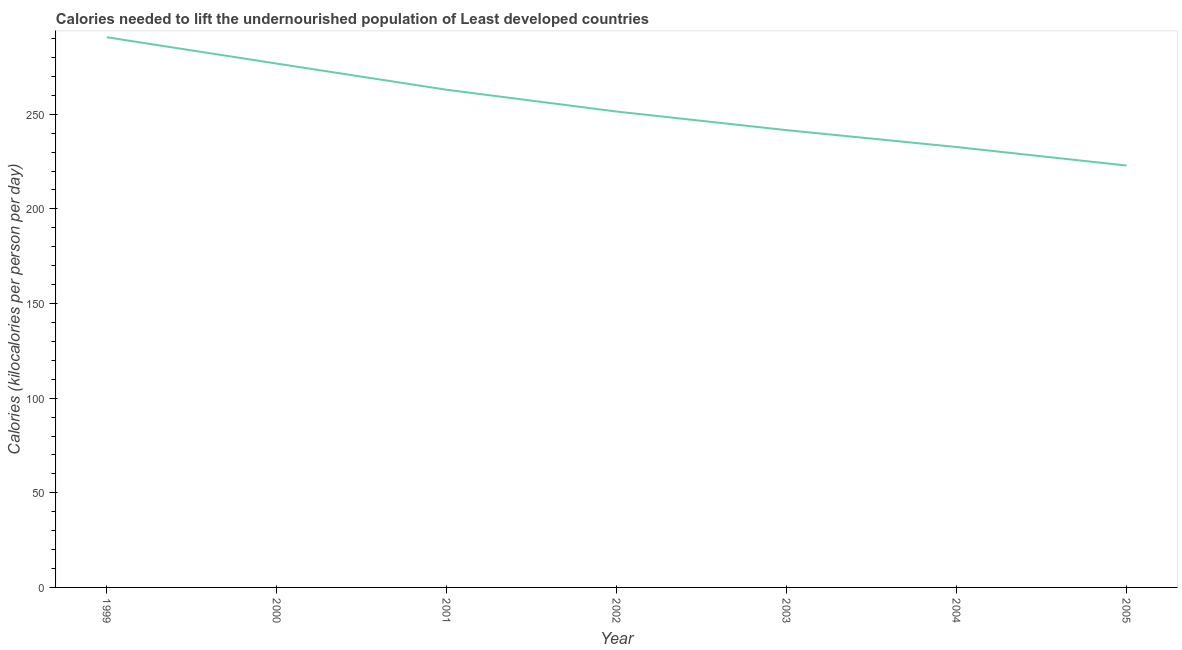What is the depth of food deficit in 2005?
Your answer should be compact. 222.9. Across all years, what is the maximum depth of food deficit?
Your answer should be compact. 290.68. Across all years, what is the minimum depth of food deficit?
Your response must be concise. 222.9. In which year was the depth of food deficit maximum?
Offer a very short reply. 1999. What is the sum of the depth of food deficit?
Ensure brevity in your answer.  1778.96. What is the difference between the depth of food deficit in 1999 and 2005?
Offer a very short reply. 67.78. What is the average depth of food deficit per year?
Offer a very short reply. 254.14. What is the median depth of food deficit?
Ensure brevity in your answer.  251.42. In how many years, is the depth of food deficit greater than 280 kilocalories?
Give a very brief answer. 1. What is the ratio of the depth of food deficit in 2000 to that in 2005?
Make the answer very short. 1.24. Is the depth of food deficit in 2003 less than that in 2005?
Provide a succinct answer. No. Is the difference between the depth of food deficit in 2001 and 2002 greater than the difference between any two years?
Provide a succinct answer. No. What is the difference between the highest and the second highest depth of food deficit?
Keep it short and to the point. 13.93. What is the difference between the highest and the lowest depth of food deficit?
Keep it short and to the point. 67.78. Does the depth of food deficit monotonically increase over the years?
Your response must be concise. No. What is the difference between two consecutive major ticks on the Y-axis?
Give a very brief answer. 50. Does the graph contain any zero values?
Offer a terse response. No. What is the title of the graph?
Your response must be concise. Calories needed to lift the undernourished population of Least developed countries. What is the label or title of the X-axis?
Keep it short and to the point. Year. What is the label or title of the Y-axis?
Your response must be concise. Calories (kilocalories per person per day). What is the Calories (kilocalories per person per day) in 1999?
Ensure brevity in your answer.  290.68. What is the Calories (kilocalories per person per day) of 2000?
Keep it short and to the point. 276.76. What is the Calories (kilocalories per person per day) in 2001?
Offer a terse response. 262.93. What is the Calories (kilocalories per person per day) in 2002?
Give a very brief answer. 251.42. What is the Calories (kilocalories per person per day) of 2003?
Keep it short and to the point. 241.59. What is the Calories (kilocalories per person per day) in 2004?
Provide a short and direct response. 232.67. What is the Calories (kilocalories per person per day) in 2005?
Offer a very short reply. 222.9. What is the difference between the Calories (kilocalories per person per day) in 1999 and 2000?
Make the answer very short. 13.93. What is the difference between the Calories (kilocalories per person per day) in 1999 and 2001?
Make the answer very short. 27.75. What is the difference between the Calories (kilocalories per person per day) in 1999 and 2002?
Your answer should be compact. 39.26. What is the difference between the Calories (kilocalories per person per day) in 1999 and 2003?
Your response must be concise. 49.09. What is the difference between the Calories (kilocalories per person per day) in 1999 and 2004?
Ensure brevity in your answer.  58.01. What is the difference between the Calories (kilocalories per person per day) in 1999 and 2005?
Your answer should be compact. 67.78. What is the difference between the Calories (kilocalories per person per day) in 2000 and 2001?
Offer a terse response. 13.82. What is the difference between the Calories (kilocalories per person per day) in 2000 and 2002?
Give a very brief answer. 25.34. What is the difference between the Calories (kilocalories per person per day) in 2000 and 2003?
Your answer should be very brief. 35.17. What is the difference between the Calories (kilocalories per person per day) in 2000 and 2004?
Provide a succinct answer. 44.08. What is the difference between the Calories (kilocalories per person per day) in 2000 and 2005?
Your answer should be very brief. 53.85. What is the difference between the Calories (kilocalories per person per day) in 2001 and 2002?
Make the answer very short. 11.51. What is the difference between the Calories (kilocalories per person per day) in 2001 and 2003?
Keep it short and to the point. 21.34. What is the difference between the Calories (kilocalories per person per day) in 2001 and 2004?
Make the answer very short. 30.26. What is the difference between the Calories (kilocalories per person per day) in 2001 and 2005?
Make the answer very short. 40.03. What is the difference between the Calories (kilocalories per person per day) in 2002 and 2003?
Keep it short and to the point. 9.83. What is the difference between the Calories (kilocalories per person per day) in 2002 and 2004?
Ensure brevity in your answer.  18.74. What is the difference between the Calories (kilocalories per person per day) in 2002 and 2005?
Give a very brief answer. 28.51. What is the difference between the Calories (kilocalories per person per day) in 2003 and 2004?
Ensure brevity in your answer.  8.92. What is the difference between the Calories (kilocalories per person per day) in 2003 and 2005?
Your response must be concise. 18.69. What is the difference between the Calories (kilocalories per person per day) in 2004 and 2005?
Your response must be concise. 9.77. What is the ratio of the Calories (kilocalories per person per day) in 1999 to that in 2001?
Your response must be concise. 1.11. What is the ratio of the Calories (kilocalories per person per day) in 1999 to that in 2002?
Your answer should be very brief. 1.16. What is the ratio of the Calories (kilocalories per person per day) in 1999 to that in 2003?
Offer a very short reply. 1.2. What is the ratio of the Calories (kilocalories per person per day) in 1999 to that in 2004?
Give a very brief answer. 1.25. What is the ratio of the Calories (kilocalories per person per day) in 1999 to that in 2005?
Your answer should be compact. 1.3. What is the ratio of the Calories (kilocalories per person per day) in 2000 to that in 2001?
Your answer should be compact. 1.05. What is the ratio of the Calories (kilocalories per person per day) in 2000 to that in 2002?
Ensure brevity in your answer.  1.1. What is the ratio of the Calories (kilocalories per person per day) in 2000 to that in 2003?
Make the answer very short. 1.15. What is the ratio of the Calories (kilocalories per person per day) in 2000 to that in 2004?
Your answer should be compact. 1.19. What is the ratio of the Calories (kilocalories per person per day) in 2000 to that in 2005?
Your answer should be compact. 1.24. What is the ratio of the Calories (kilocalories per person per day) in 2001 to that in 2002?
Give a very brief answer. 1.05. What is the ratio of the Calories (kilocalories per person per day) in 2001 to that in 2003?
Make the answer very short. 1.09. What is the ratio of the Calories (kilocalories per person per day) in 2001 to that in 2004?
Ensure brevity in your answer.  1.13. What is the ratio of the Calories (kilocalories per person per day) in 2001 to that in 2005?
Offer a very short reply. 1.18. What is the ratio of the Calories (kilocalories per person per day) in 2002 to that in 2003?
Provide a succinct answer. 1.04. What is the ratio of the Calories (kilocalories per person per day) in 2002 to that in 2004?
Your response must be concise. 1.08. What is the ratio of the Calories (kilocalories per person per day) in 2002 to that in 2005?
Ensure brevity in your answer.  1.13. What is the ratio of the Calories (kilocalories per person per day) in 2003 to that in 2004?
Your answer should be compact. 1.04. What is the ratio of the Calories (kilocalories per person per day) in 2003 to that in 2005?
Your response must be concise. 1.08. What is the ratio of the Calories (kilocalories per person per day) in 2004 to that in 2005?
Offer a very short reply. 1.04. 